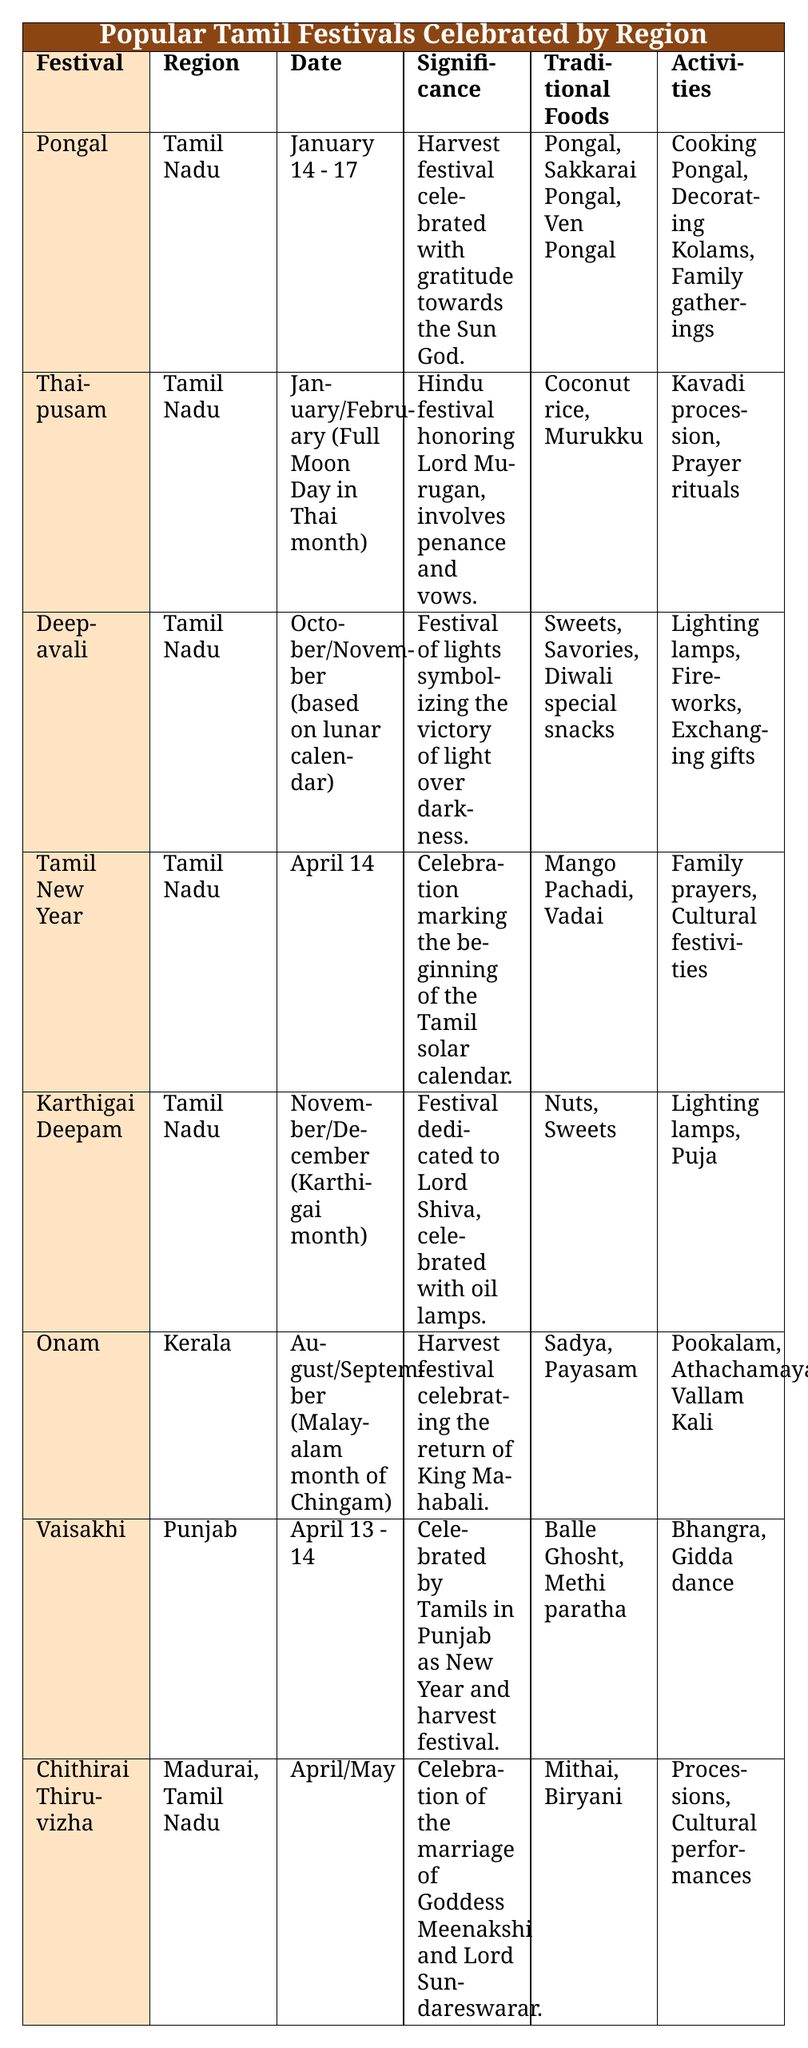What is the festival celebrated in Tamil Nadu in January? The table lists "Pongal" and "Thaipusam" both occurring in January in Tamil Nadu.
Answer: Pongal What are the traditional foods associated with Onam? Referring to the table, the foods for Onam are listed as "Sadya" and "Payasam."
Answer: Sadya, Payasam Is Deepavali celebrated in Tamil Nadu? The table indicates that Deepavali is indeed celebrated in Tamil Nadu.
Answer: Yes Which festival involves the lighting of lamps and has significance linked to Lord Shiva in Tamil Nadu? The festival "Karthigai Deepam" is dedicated to Lord Shiva and involves lighting lamps according to the table.
Answer: Karthigai Deepam How many festivals listed are celebrated in Tamil Nadu? Upon counting in the table, there are five festivals specifically listed for Tamil Nadu: Pongal, Thaipusam, Deepavali, Tamil New Year, and Karthigai Deepam.
Answer: 5 What is the significance of the Tamil New Year festival? The table states that the significance is "Celebration marking the beginning of the Tamil solar calendar."
Answer: Celebration marking the beginning of the Tamil solar calendar How many traditional foods are associated with the festival of Chithirai Thiruvizha? The table lists two traditional foods for Chithirai Thiruvizha: "Mithai" and "Biryani."
Answer: 2 Which festival is celebrated in Kerala during August/September? The table indicates that "Onam" is the festival celebrated in Kerala during this time.
Answer: Onam What are the activities associated with the Thaipusam festival? The table outlines activities for Thaipusam as "Kavadi procession" and "Prayer rituals."
Answer: Kavadi procession, Prayer rituals If you were to compare the number of traditional foods in Pongal and Karthigai Deepam, which has more? The table shows that Pongal has three traditional foods ("Pongal," "Sakkarai Pongal," "Ven Pongal") while Karthigai Deepam has two ("Nuts," "Sweets"). Thus, Pongal has more.
Answer: Pongal has more Is Vaisakhi celebrated only in Punjab according to the data? The table indicates that Vaisakhi is celebrated specifically in Punjab and mentions that it is a New Year and harvest festival for Tamils.
Answer: No 